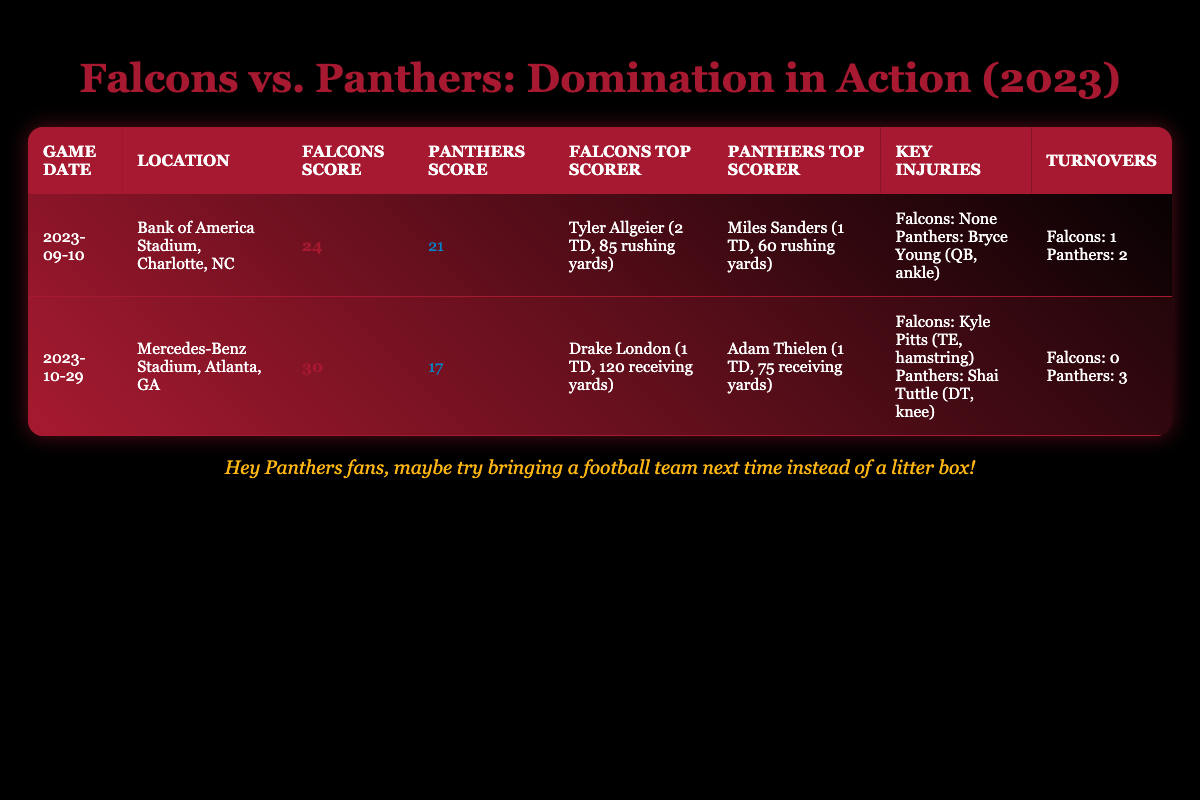What was the highest score achieved by the Falcons in their games against the Panthers? The Falcons scored 30 points in the game on October 29, 2023, which is the highest score listed in the table.
Answer: 30 How many total turnovers did the Panthers have across both games? In the September 10 game, the Panthers had 2 turnovers, and in the October 29 game, they had 3 turnovers. Adding these together: 2 + 3 = 5.
Answer: 5 Did the Falcons have any key injuries in the first game? The table indicates that the Falcons had "None" listed for key injuries in the September 10 game. Thus, there were no injuries reported for them.
Answer: No Who was the top scorer for the Panthers in both games combined? The table lists Miles Sanders as the top scorer for the Panthers in the first game with 1 touchdown, and Adam Thielen as the top scorer in the second game, also with 1 touchdown. Since both scored one touchdown, there is no single top scorer here, but each scored equally.
Answer: N/A What was the difference in scores between the Falcons and Panthers in the first game? In the first game, the Falcons scored 24 points and the Panthers scored 21 points. The difference is 24 - 21 = 3.
Answer: 3 Which team had a higher total rushing yardage by its top scorer in the first game? The Falcons' Tyler Allgeier had 85 rushing yards, while Miles Sanders of the Panthers had 60 rushing yards. Since 85 > 60, the Falcons' top scorer had more rushing yards.
Answer: Falcons In how many instances did the Falcons and Panthers each score more than 20 points in their matchups? The Falcons scored more than 20 points in both games (24 and 30), while the Panthers scored more than 20 points only in the first game (21). Therefore, the Falcons scored above 20 in both games, while the Panthers achieved this once.
Answer: Falcons: 2, Panthers: 1 Was there any instance where the Panthers had fewer turnovers than the Falcons in a game? Analyzing each game's turnovers, the Falcons had 1 turnover in the first game and 0 in the second game, while the Panthers had 2 turnovers in the first game and 3 in the second game. In both games, the Panthers had more turnovers than the Falcons.
Answer: No 